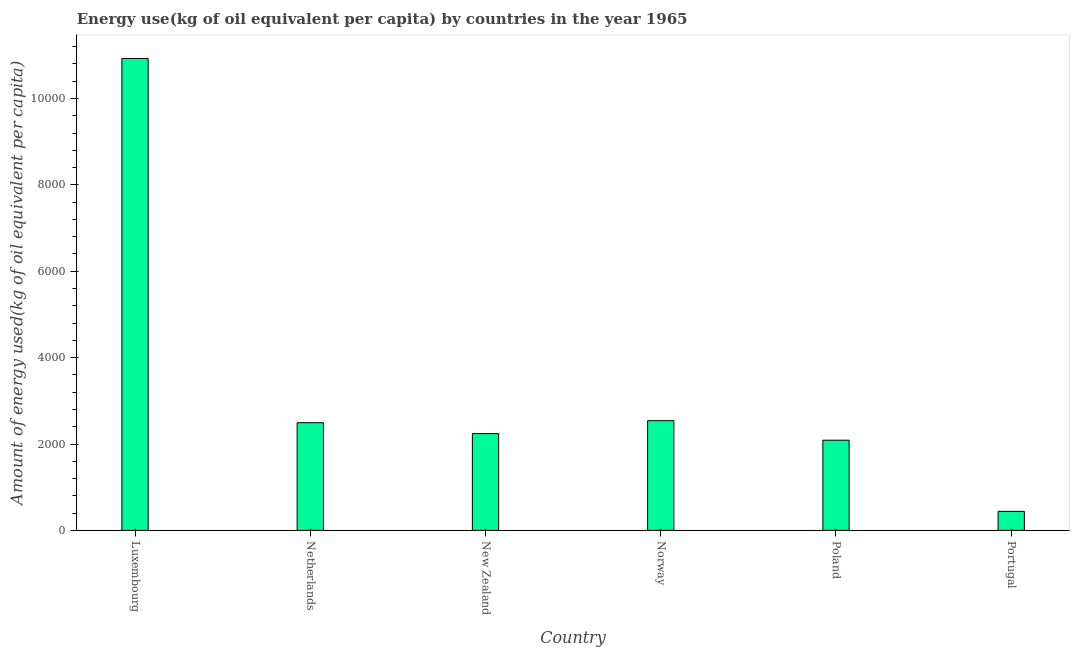Does the graph contain any zero values?
Your answer should be very brief. No. What is the title of the graph?
Provide a succinct answer. Energy use(kg of oil equivalent per capita) by countries in the year 1965. What is the label or title of the Y-axis?
Keep it short and to the point. Amount of energy used(kg of oil equivalent per capita). What is the amount of energy used in Norway?
Provide a short and direct response. 2539.6. Across all countries, what is the maximum amount of energy used?
Give a very brief answer. 1.09e+04. Across all countries, what is the minimum amount of energy used?
Offer a terse response. 440.88. In which country was the amount of energy used maximum?
Provide a short and direct response. Luxembourg. What is the sum of the amount of energy used?
Offer a very short reply. 2.07e+04. What is the difference between the amount of energy used in Netherlands and Portugal?
Ensure brevity in your answer.  2052.27. What is the average amount of energy used per country?
Provide a short and direct response. 3454.91. What is the median amount of energy used?
Your response must be concise. 2367.28. What is the ratio of the amount of energy used in Norway to that in Poland?
Provide a succinct answer. 1.22. Is the difference between the amount of energy used in Luxembourg and Portugal greater than the difference between any two countries?
Make the answer very short. Yes. What is the difference between the highest and the second highest amount of energy used?
Your response must be concise. 8386.8. Is the sum of the amount of energy used in Luxembourg and Netherlands greater than the maximum amount of energy used across all countries?
Provide a succinct answer. Yes. What is the difference between the highest and the lowest amount of energy used?
Offer a terse response. 1.05e+04. Are all the bars in the graph horizontal?
Provide a short and direct response. No. How many countries are there in the graph?
Provide a short and direct response. 6. What is the difference between two consecutive major ticks on the Y-axis?
Your answer should be very brief. 2000. What is the Amount of energy used(kg of oil equivalent per capita) in Luxembourg?
Ensure brevity in your answer.  1.09e+04. What is the Amount of energy used(kg of oil equivalent per capita) of Netherlands?
Provide a succinct answer. 2493.15. What is the Amount of energy used(kg of oil equivalent per capita) of New Zealand?
Make the answer very short. 2241.42. What is the Amount of energy used(kg of oil equivalent per capita) of Norway?
Offer a terse response. 2539.6. What is the Amount of energy used(kg of oil equivalent per capita) in Poland?
Ensure brevity in your answer.  2088.01. What is the Amount of energy used(kg of oil equivalent per capita) in Portugal?
Provide a succinct answer. 440.88. What is the difference between the Amount of energy used(kg of oil equivalent per capita) in Luxembourg and Netherlands?
Your response must be concise. 8433.24. What is the difference between the Amount of energy used(kg of oil equivalent per capita) in Luxembourg and New Zealand?
Offer a terse response. 8684.98. What is the difference between the Amount of energy used(kg of oil equivalent per capita) in Luxembourg and Norway?
Provide a short and direct response. 8386.8. What is the difference between the Amount of energy used(kg of oil equivalent per capita) in Luxembourg and Poland?
Provide a short and direct response. 8838.38. What is the difference between the Amount of energy used(kg of oil equivalent per capita) in Luxembourg and Portugal?
Provide a succinct answer. 1.05e+04. What is the difference between the Amount of energy used(kg of oil equivalent per capita) in Netherlands and New Zealand?
Your response must be concise. 251.74. What is the difference between the Amount of energy used(kg of oil equivalent per capita) in Netherlands and Norway?
Offer a terse response. -46.44. What is the difference between the Amount of energy used(kg of oil equivalent per capita) in Netherlands and Poland?
Keep it short and to the point. 405.14. What is the difference between the Amount of energy used(kg of oil equivalent per capita) in Netherlands and Portugal?
Ensure brevity in your answer.  2052.27. What is the difference between the Amount of energy used(kg of oil equivalent per capita) in New Zealand and Norway?
Your response must be concise. -298.18. What is the difference between the Amount of energy used(kg of oil equivalent per capita) in New Zealand and Poland?
Your answer should be compact. 153.4. What is the difference between the Amount of energy used(kg of oil equivalent per capita) in New Zealand and Portugal?
Offer a terse response. 1800.53. What is the difference between the Amount of energy used(kg of oil equivalent per capita) in Norway and Poland?
Your answer should be very brief. 451.59. What is the difference between the Amount of energy used(kg of oil equivalent per capita) in Norway and Portugal?
Provide a short and direct response. 2098.71. What is the difference between the Amount of energy used(kg of oil equivalent per capita) in Poland and Portugal?
Ensure brevity in your answer.  1647.13. What is the ratio of the Amount of energy used(kg of oil equivalent per capita) in Luxembourg to that in Netherlands?
Offer a very short reply. 4.38. What is the ratio of the Amount of energy used(kg of oil equivalent per capita) in Luxembourg to that in New Zealand?
Provide a short and direct response. 4.88. What is the ratio of the Amount of energy used(kg of oil equivalent per capita) in Luxembourg to that in Norway?
Provide a succinct answer. 4.3. What is the ratio of the Amount of energy used(kg of oil equivalent per capita) in Luxembourg to that in Poland?
Offer a terse response. 5.23. What is the ratio of the Amount of energy used(kg of oil equivalent per capita) in Luxembourg to that in Portugal?
Offer a terse response. 24.78. What is the ratio of the Amount of energy used(kg of oil equivalent per capita) in Netherlands to that in New Zealand?
Make the answer very short. 1.11. What is the ratio of the Amount of energy used(kg of oil equivalent per capita) in Netherlands to that in Norway?
Your answer should be very brief. 0.98. What is the ratio of the Amount of energy used(kg of oil equivalent per capita) in Netherlands to that in Poland?
Give a very brief answer. 1.19. What is the ratio of the Amount of energy used(kg of oil equivalent per capita) in Netherlands to that in Portugal?
Provide a short and direct response. 5.66. What is the ratio of the Amount of energy used(kg of oil equivalent per capita) in New Zealand to that in Norway?
Offer a terse response. 0.88. What is the ratio of the Amount of energy used(kg of oil equivalent per capita) in New Zealand to that in Poland?
Provide a short and direct response. 1.07. What is the ratio of the Amount of energy used(kg of oil equivalent per capita) in New Zealand to that in Portugal?
Your answer should be compact. 5.08. What is the ratio of the Amount of energy used(kg of oil equivalent per capita) in Norway to that in Poland?
Your answer should be compact. 1.22. What is the ratio of the Amount of energy used(kg of oil equivalent per capita) in Norway to that in Portugal?
Provide a succinct answer. 5.76. What is the ratio of the Amount of energy used(kg of oil equivalent per capita) in Poland to that in Portugal?
Offer a very short reply. 4.74. 